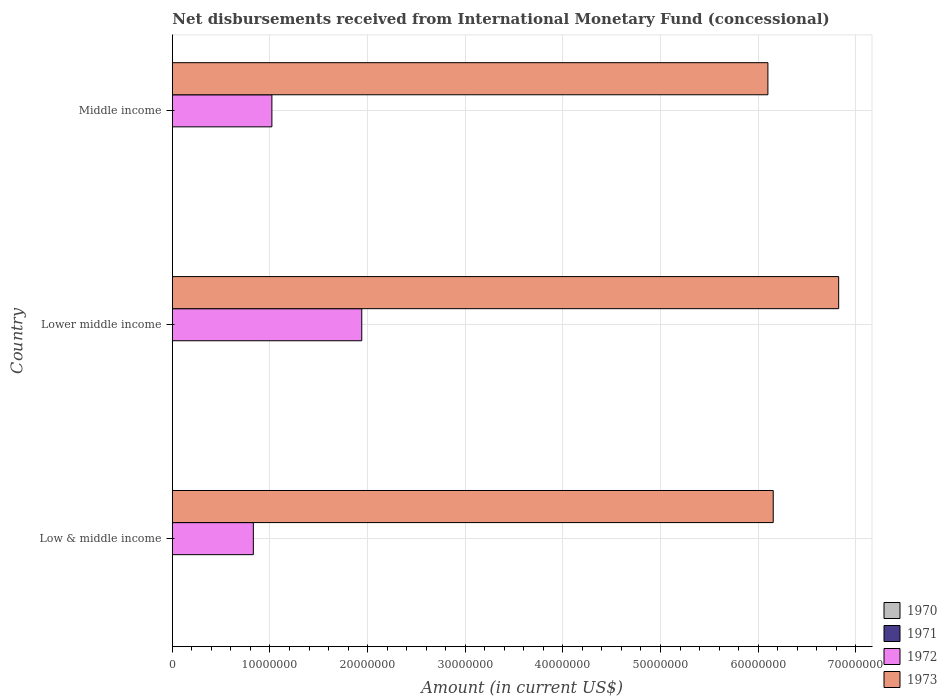How many groups of bars are there?
Make the answer very short. 3. Are the number of bars on each tick of the Y-axis equal?
Your response must be concise. Yes. How many bars are there on the 2nd tick from the top?
Your answer should be compact. 2. What is the label of the 2nd group of bars from the top?
Your answer should be compact. Lower middle income. In how many cases, is the number of bars for a given country not equal to the number of legend labels?
Your response must be concise. 3. What is the amount of disbursements received from International Monetary Fund in 1973 in Middle income?
Keep it short and to the point. 6.10e+07. Across all countries, what is the maximum amount of disbursements received from International Monetary Fund in 1972?
Give a very brief answer. 1.94e+07. Across all countries, what is the minimum amount of disbursements received from International Monetary Fund in 1972?
Provide a succinct answer. 8.30e+06. In which country was the amount of disbursements received from International Monetary Fund in 1973 maximum?
Your answer should be very brief. Lower middle income. What is the total amount of disbursements received from International Monetary Fund in 1973 in the graph?
Provide a succinct answer. 1.91e+08. What is the difference between the amount of disbursements received from International Monetary Fund in 1972 in Low & middle income and that in Middle income?
Offer a terse response. -1.90e+06. What is the difference between the amount of disbursements received from International Monetary Fund in 1970 in Lower middle income and the amount of disbursements received from International Monetary Fund in 1972 in Middle income?
Keep it short and to the point. -1.02e+07. What is the average amount of disbursements received from International Monetary Fund in 1970 per country?
Give a very brief answer. 0. What is the difference between the amount of disbursements received from International Monetary Fund in 1972 and amount of disbursements received from International Monetary Fund in 1973 in Lower middle income?
Your answer should be very brief. -4.89e+07. In how many countries, is the amount of disbursements received from International Monetary Fund in 1973 greater than 54000000 US$?
Make the answer very short. 3. What is the ratio of the amount of disbursements received from International Monetary Fund in 1973 in Low & middle income to that in Middle income?
Provide a short and direct response. 1.01. Is the amount of disbursements received from International Monetary Fund in 1972 in Low & middle income less than that in Middle income?
Provide a short and direct response. Yes. What is the difference between the highest and the second highest amount of disbursements received from International Monetary Fund in 1973?
Provide a succinct answer. 6.70e+06. What is the difference between the highest and the lowest amount of disbursements received from International Monetary Fund in 1973?
Your answer should be very brief. 7.25e+06. Is the sum of the amount of disbursements received from International Monetary Fund in 1973 in Lower middle income and Middle income greater than the maximum amount of disbursements received from International Monetary Fund in 1970 across all countries?
Make the answer very short. Yes. Is it the case that in every country, the sum of the amount of disbursements received from International Monetary Fund in 1973 and amount of disbursements received from International Monetary Fund in 1970 is greater than the amount of disbursements received from International Monetary Fund in 1971?
Your answer should be very brief. Yes. How many bars are there?
Offer a terse response. 6. Are the values on the major ticks of X-axis written in scientific E-notation?
Your response must be concise. No. Does the graph contain any zero values?
Your answer should be compact. Yes. How are the legend labels stacked?
Your response must be concise. Vertical. What is the title of the graph?
Ensure brevity in your answer.  Net disbursements received from International Monetary Fund (concessional). What is the label or title of the Y-axis?
Offer a terse response. Country. What is the Amount (in current US$) in 1970 in Low & middle income?
Offer a terse response. 0. What is the Amount (in current US$) in 1972 in Low & middle income?
Your response must be concise. 8.30e+06. What is the Amount (in current US$) in 1973 in Low & middle income?
Give a very brief answer. 6.16e+07. What is the Amount (in current US$) of 1972 in Lower middle income?
Make the answer very short. 1.94e+07. What is the Amount (in current US$) in 1973 in Lower middle income?
Ensure brevity in your answer.  6.83e+07. What is the Amount (in current US$) of 1971 in Middle income?
Offer a terse response. 0. What is the Amount (in current US$) of 1972 in Middle income?
Your answer should be very brief. 1.02e+07. What is the Amount (in current US$) of 1973 in Middle income?
Give a very brief answer. 6.10e+07. Across all countries, what is the maximum Amount (in current US$) in 1972?
Your answer should be compact. 1.94e+07. Across all countries, what is the maximum Amount (in current US$) in 1973?
Offer a very short reply. 6.83e+07. Across all countries, what is the minimum Amount (in current US$) of 1972?
Provide a short and direct response. 8.30e+06. Across all countries, what is the minimum Amount (in current US$) in 1973?
Your answer should be compact. 6.10e+07. What is the total Amount (in current US$) of 1972 in the graph?
Give a very brief answer. 3.79e+07. What is the total Amount (in current US$) in 1973 in the graph?
Your response must be concise. 1.91e+08. What is the difference between the Amount (in current US$) in 1972 in Low & middle income and that in Lower middle income?
Keep it short and to the point. -1.11e+07. What is the difference between the Amount (in current US$) in 1973 in Low & middle income and that in Lower middle income?
Offer a terse response. -6.70e+06. What is the difference between the Amount (in current US$) in 1972 in Low & middle income and that in Middle income?
Provide a succinct answer. -1.90e+06. What is the difference between the Amount (in current US$) in 1973 in Low & middle income and that in Middle income?
Your answer should be compact. 5.46e+05. What is the difference between the Amount (in current US$) in 1972 in Lower middle income and that in Middle income?
Ensure brevity in your answer.  9.21e+06. What is the difference between the Amount (in current US$) of 1973 in Lower middle income and that in Middle income?
Make the answer very short. 7.25e+06. What is the difference between the Amount (in current US$) of 1972 in Low & middle income and the Amount (in current US$) of 1973 in Lower middle income?
Keep it short and to the point. -6.00e+07. What is the difference between the Amount (in current US$) in 1972 in Low & middle income and the Amount (in current US$) in 1973 in Middle income?
Provide a succinct answer. -5.27e+07. What is the difference between the Amount (in current US$) in 1972 in Lower middle income and the Amount (in current US$) in 1973 in Middle income?
Keep it short and to the point. -4.16e+07. What is the average Amount (in current US$) in 1970 per country?
Offer a terse response. 0. What is the average Amount (in current US$) of 1972 per country?
Your response must be concise. 1.26e+07. What is the average Amount (in current US$) in 1973 per country?
Provide a short and direct response. 6.36e+07. What is the difference between the Amount (in current US$) in 1972 and Amount (in current US$) in 1973 in Low & middle income?
Your answer should be compact. -5.33e+07. What is the difference between the Amount (in current US$) in 1972 and Amount (in current US$) in 1973 in Lower middle income?
Give a very brief answer. -4.89e+07. What is the difference between the Amount (in current US$) in 1972 and Amount (in current US$) in 1973 in Middle income?
Provide a short and direct response. -5.08e+07. What is the ratio of the Amount (in current US$) of 1972 in Low & middle income to that in Lower middle income?
Make the answer very short. 0.43. What is the ratio of the Amount (in current US$) of 1973 in Low & middle income to that in Lower middle income?
Provide a short and direct response. 0.9. What is the ratio of the Amount (in current US$) in 1972 in Low & middle income to that in Middle income?
Make the answer very short. 0.81. What is the ratio of the Amount (in current US$) of 1972 in Lower middle income to that in Middle income?
Provide a succinct answer. 1.9. What is the ratio of the Amount (in current US$) in 1973 in Lower middle income to that in Middle income?
Provide a short and direct response. 1.12. What is the difference between the highest and the second highest Amount (in current US$) in 1972?
Offer a very short reply. 9.21e+06. What is the difference between the highest and the second highest Amount (in current US$) in 1973?
Keep it short and to the point. 6.70e+06. What is the difference between the highest and the lowest Amount (in current US$) of 1972?
Make the answer very short. 1.11e+07. What is the difference between the highest and the lowest Amount (in current US$) of 1973?
Your response must be concise. 7.25e+06. 